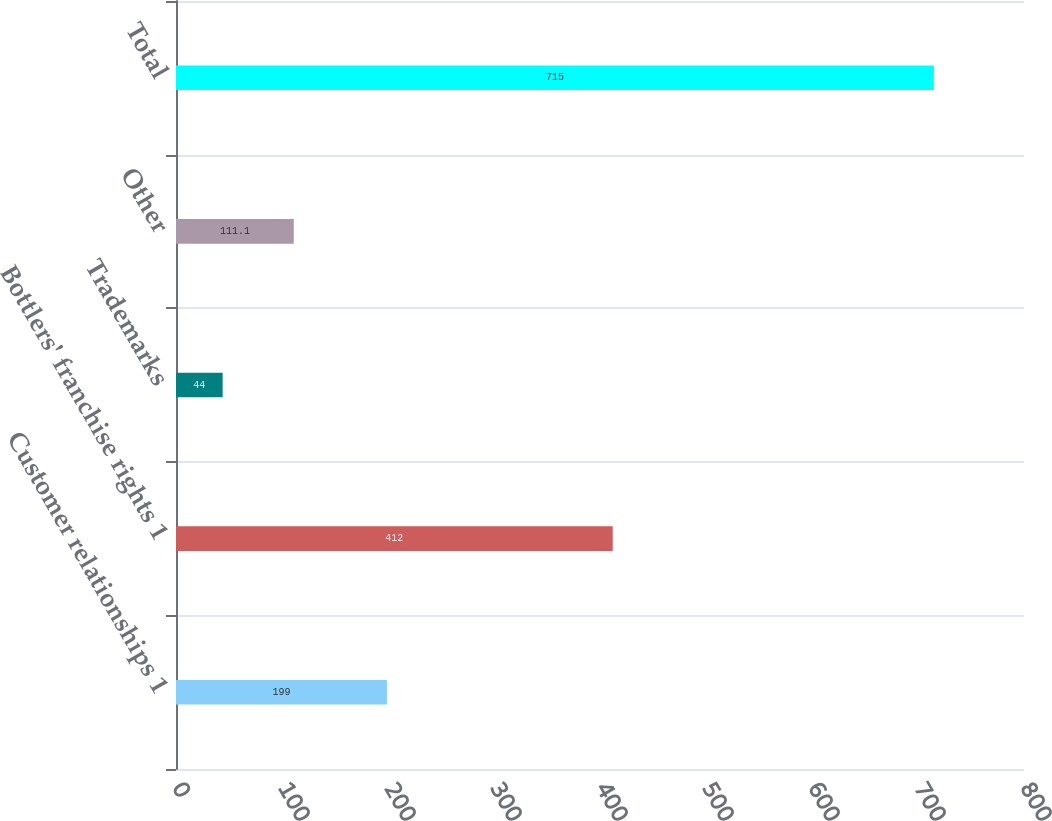Convert chart. <chart><loc_0><loc_0><loc_500><loc_500><bar_chart><fcel>Customer relationships 1<fcel>Bottlers' franchise rights 1<fcel>Trademarks<fcel>Other<fcel>Total<nl><fcel>199<fcel>412<fcel>44<fcel>111.1<fcel>715<nl></chart> 